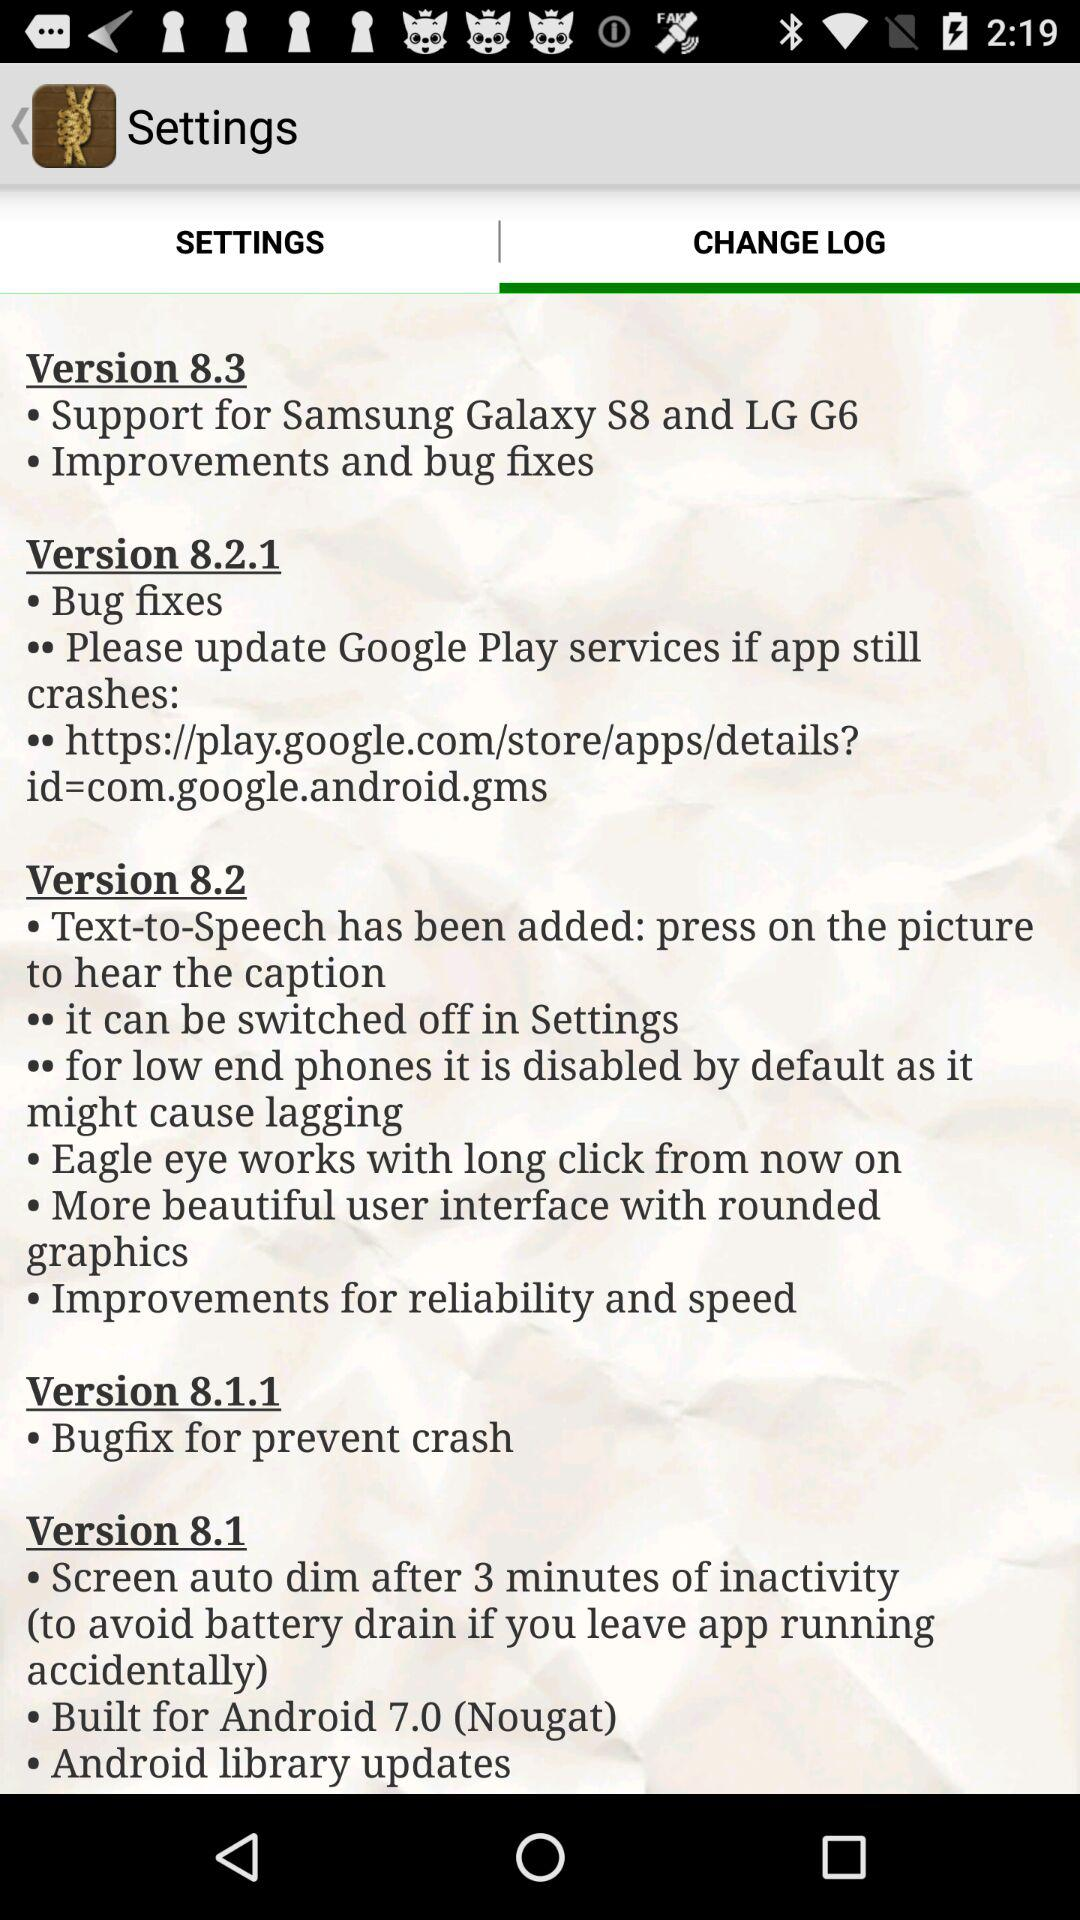What's new in version 8.3? The new updates in version 8.3 are "Support for Samsung Galaxy S8 and LG G6" and "Improvements and bug fixes". 